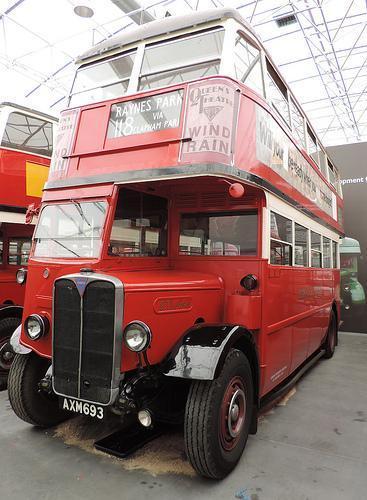How many wheels are visible?
Give a very brief answer. 3. 